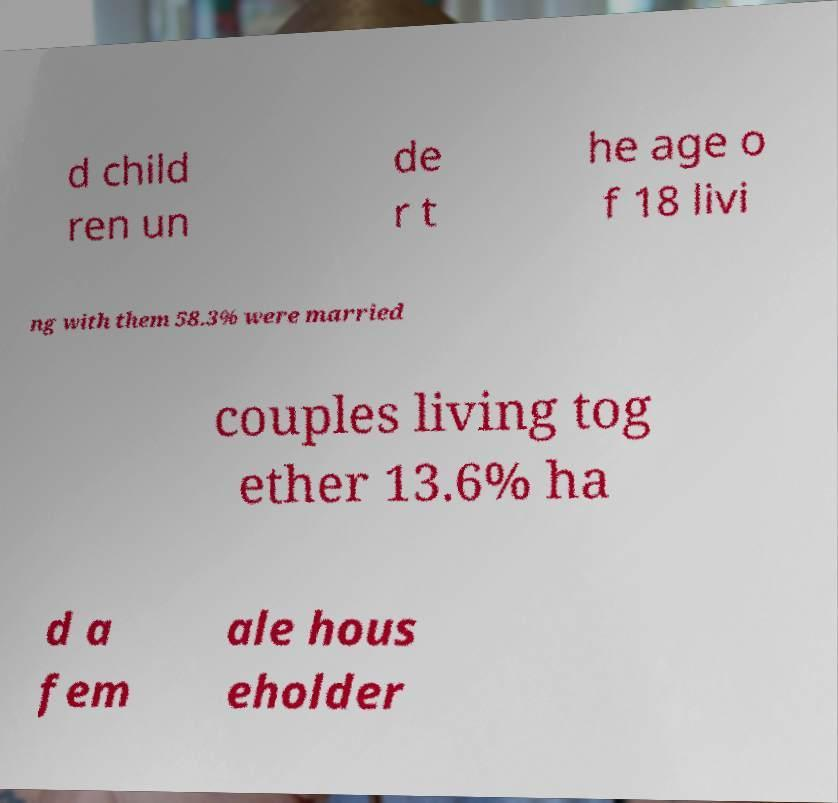Could you assist in decoding the text presented in this image and type it out clearly? d child ren un de r t he age o f 18 livi ng with them 58.3% were married couples living tog ether 13.6% ha d a fem ale hous eholder 